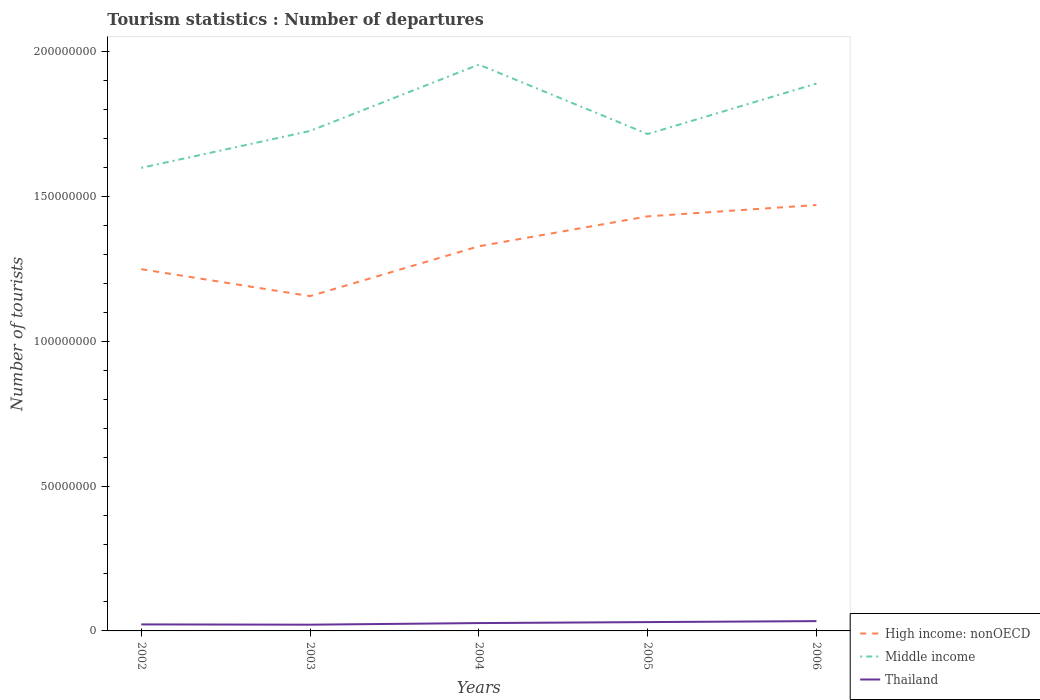How many different coloured lines are there?
Provide a succinct answer. 3. Does the line corresponding to Thailand intersect with the line corresponding to Middle income?
Your answer should be very brief. No. Across all years, what is the maximum number of tourist departures in High income: nonOECD?
Keep it short and to the point. 1.16e+08. What is the total number of tourist departures in Thailand in the graph?
Provide a succinct answer. -3.38e+05. What is the difference between the highest and the second highest number of tourist departures in Thailand?
Offer a very short reply. 1.23e+06. Is the number of tourist departures in Thailand strictly greater than the number of tourist departures in Middle income over the years?
Make the answer very short. Yes. How many lines are there?
Offer a terse response. 3. How many years are there in the graph?
Keep it short and to the point. 5. What is the title of the graph?
Your answer should be very brief. Tourism statistics : Number of departures. Does "Lao PDR" appear as one of the legend labels in the graph?
Give a very brief answer. No. What is the label or title of the Y-axis?
Make the answer very short. Number of tourists. What is the Number of tourists of High income: nonOECD in 2002?
Make the answer very short. 1.25e+08. What is the Number of tourists in Middle income in 2002?
Keep it short and to the point. 1.60e+08. What is the Number of tourists in Thailand in 2002?
Provide a succinct answer. 2.25e+06. What is the Number of tourists in High income: nonOECD in 2003?
Your answer should be very brief. 1.16e+08. What is the Number of tourists of Middle income in 2003?
Your answer should be compact. 1.73e+08. What is the Number of tourists of Thailand in 2003?
Give a very brief answer. 2.15e+06. What is the Number of tourists in High income: nonOECD in 2004?
Keep it short and to the point. 1.33e+08. What is the Number of tourists of Middle income in 2004?
Provide a short and direct response. 1.96e+08. What is the Number of tourists in Thailand in 2004?
Keep it short and to the point. 2.71e+06. What is the Number of tourists in High income: nonOECD in 2005?
Provide a short and direct response. 1.43e+08. What is the Number of tourists of Middle income in 2005?
Provide a short and direct response. 1.72e+08. What is the Number of tourists of Thailand in 2005?
Provide a succinct answer. 3.05e+06. What is the Number of tourists in High income: nonOECD in 2006?
Provide a short and direct response. 1.47e+08. What is the Number of tourists in Middle income in 2006?
Keep it short and to the point. 1.89e+08. What is the Number of tourists of Thailand in 2006?
Ensure brevity in your answer.  3.38e+06. Across all years, what is the maximum Number of tourists of High income: nonOECD?
Provide a succinct answer. 1.47e+08. Across all years, what is the maximum Number of tourists of Middle income?
Give a very brief answer. 1.96e+08. Across all years, what is the maximum Number of tourists in Thailand?
Offer a terse response. 3.38e+06. Across all years, what is the minimum Number of tourists of High income: nonOECD?
Provide a short and direct response. 1.16e+08. Across all years, what is the minimum Number of tourists in Middle income?
Offer a terse response. 1.60e+08. Across all years, what is the minimum Number of tourists in Thailand?
Provide a succinct answer. 2.15e+06. What is the total Number of tourists of High income: nonOECD in the graph?
Provide a succinct answer. 6.64e+08. What is the total Number of tourists in Middle income in the graph?
Provide a short and direct response. 8.89e+08. What is the total Number of tourists in Thailand in the graph?
Your answer should be compact. 1.35e+07. What is the difference between the Number of tourists of High income: nonOECD in 2002 and that in 2003?
Offer a very short reply. 9.30e+06. What is the difference between the Number of tourists of Middle income in 2002 and that in 2003?
Provide a short and direct response. -1.27e+07. What is the difference between the Number of tourists of Thailand in 2002 and that in 2003?
Your answer should be compact. 9.80e+04. What is the difference between the Number of tourists in High income: nonOECD in 2002 and that in 2004?
Make the answer very short. -7.91e+06. What is the difference between the Number of tourists of Middle income in 2002 and that in 2004?
Provide a succinct answer. -3.57e+07. What is the difference between the Number of tourists of Thailand in 2002 and that in 2004?
Your response must be concise. -4.59e+05. What is the difference between the Number of tourists in High income: nonOECD in 2002 and that in 2005?
Make the answer very short. -1.82e+07. What is the difference between the Number of tourists in Middle income in 2002 and that in 2005?
Offer a terse response. -1.17e+07. What is the difference between the Number of tourists of Thailand in 2002 and that in 2005?
Provide a short and direct response. -7.97e+05. What is the difference between the Number of tourists of High income: nonOECD in 2002 and that in 2006?
Offer a terse response. -2.22e+07. What is the difference between the Number of tourists of Middle income in 2002 and that in 2006?
Ensure brevity in your answer.  -2.91e+07. What is the difference between the Number of tourists in Thailand in 2002 and that in 2006?
Your answer should be compact. -1.13e+06. What is the difference between the Number of tourists in High income: nonOECD in 2003 and that in 2004?
Ensure brevity in your answer.  -1.72e+07. What is the difference between the Number of tourists in Middle income in 2003 and that in 2004?
Keep it short and to the point. -2.29e+07. What is the difference between the Number of tourists in Thailand in 2003 and that in 2004?
Provide a succinct answer. -5.57e+05. What is the difference between the Number of tourists of High income: nonOECD in 2003 and that in 2005?
Keep it short and to the point. -2.75e+07. What is the difference between the Number of tourists in Middle income in 2003 and that in 2005?
Make the answer very short. 1.05e+06. What is the difference between the Number of tourists in Thailand in 2003 and that in 2005?
Your answer should be very brief. -8.95e+05. What is the difference between the Number of tourists in High income: nonOECD in 2003 and that in 2006?
Provide a succinct answer. -3.15e+07. What is the difference between the Number of tourists in Middle income in 2003 and that in 2006?
Provide a short and direct response. -1.64e+07. What is the difference between the Number of tourists in Thailand in 2003 and that in 2006?
Offer a terse response. -1.23e+06. What is the difference between the Number of tourists of High income: nonOECD in 2004 and that in 2005?
Give a very brief answer. -1.03e+07. What is the difference between the Number of tourists of Middle income in 2004 and that in 2005?
Offer a terse response. 2.40e+07. What is the difference between the Number of tourists in Thailand in 2004 and that in 2005?
Provide a succinct answer. -3.38e+05. What is the difference between the Number of tourists in High income: nonOECD in 2004 and that in 2006?
Provide a short and direct response. -1.43e+07. What is the difference between the Number of tourists of Middle income in 2004 and that in 2006?
Provide a succinct answer. 6.56e+06. What is the difference between the Number of tourists of Thailand in 2004 and that in 2006?
Your answer should be compact. -6.73e+05. What is the difference between the Number of tourists of High income: nonOECD in 2005 and that in 2006?
Offer a very short reply. -3.92e+06. What is the difference between the Number of tourists in Middle income in 2005 and that in 2006?
Ensure brevity in your answer.  -1.74e+07. What is the difference between the Number of tourists of Thailand in 2005 and that in 2006?
Provide a short and direct response. -3.35e+05. What is the difference between the Number of tourists in High income: nonOECD in 2002 and the Number of tourists in Middle income in 2003?
Your answer should be very brief. -4.77e+07. What is the difference between the Number of tourists of High income: nonOECD in 2002 and the Number of tourists of Thailand in 2003?
Your answer should be compact. 1.23e+08. What is the difference between the Number of tourists of Middle income in 2002 and the Number of tourists of Thailand in 2003?
Keep it short and to the point. 1.58e+08. What is the difference between the Number of tourists of High income: nonOECD in 2002 and the Number of tourists of Middle income in 2004?
Ensure brevity in your answer.  -7.07e+07. What is the difference between the Number of tourists of High income: nonOECD in 2002 and the Number of tourists of Thailand in 2004?
Your response must be concise. 1.22e+08. What is the difference between the Number of tourists in Middle income in 2002 and the Number of tourists in Thailand in 2004?
Make the answer very short. 1.57e+08. What is the difference between the Number of tourists in High income: nonOECD in 2002 and the Number of tourists in Middle income in 2005?
Your answer should be compact. -4.67e+07. What is the difference between the Number of tourists of High income: nonOECD in 2002 and the Number of tourists of Thailand in 2005?
Offer a terse response. 1.22e+08. What is the difference between the Number of tourists of Middle income in 2002 and the Number of tourists of Thailand in 2005?
Offer a terse response. 1.57e+08. What is the difference between the Number of tourists in High income: nonOECD in 2002 and the Number of tourists in Middle income in 2006?
Give a very brief answer. -6.41e+07. What is the difference between the Number of tourists in High income: nonOECD in 2002 and the Number of tourists in Thailand in 2006?
Offer a terse response. 1.22e+08. What is the difference between the Number of tourists in Middle income in 2002 and the Number of tourists in Thailand in 2006?
Provide a succinct answer. 1.57e+08. What is the difference between the Number of tourists of High income: nonOECD in 2003 and the Number of tourists of Middle income in 2004?
Make the answer very short. -8.00e+07. What is the difference between the Number of tourists in High income: nonOECD in 2003 and the Number of tourists in Thailand in 2004?
Give a very brief answer. 1.13e+08. What is the difference between the Number of tourists of Middle income in 2003 and the Number of tourists of Thailand in 2004?
Keep it short and to the point. 1.70e+08. What is the difference between the Number of tourists in High income: nonOECD in 2003 and the Number of tourists in Middle income in 2005?
Ensure brevity in your answer.  -5.60e+07. What is the difference between the Number of tourists in High income: nonOECD in 2003 and the Number of tourists in Thailand in 2005?
Give a very brief answer. 1.13e+08. What is the difference between the Number of tourists in Middle income in 2003 and the Number of tourists in Thailand in 2005?
Offer a terse response. 1.70e+08. What is the difference between the Number of tourists of High income: nonOECD in 2003 and the Number of tourists of Middle income in 2006?
Ensure brevity in your answer.  -7.34e+07. What is the difference between the Number of tourists of High income: nonOECD in 2003 and the Number of tourists of Thailand in 2006?
Provide a succinct answer. 1.12e+08. What is the difference between the Number of tourists in Middle income in 2003 and the Number of tourists in Thailand in 2006?
Make the answer very short. 1.69e+08. What is the difference between the Number of tourists in High income: nonOECD in 2004 and the Number of tourists in Middle income in 2005?
Your answer should be very brief. -3.88e+07. What is the difference between the Number of tourists of High income: nonOECD in 2004 and the Number of tourists of Thailand in 2005?
Ensure brevity in your answer.  1.30e+08. What is the difference between the Number of tourists of Middle income in 2004 and the Number of tourists of Thailand in 2005?
Make the answer very short. 1.93e+08. What is the difference between the Number of tourists of High income: nonOECD in 2004 and the Number of tourists of Middle income in 2006?
Offer a terse response. -5.62e+07. What is the difference between the Number of tourists of High income: nonOECD in 2004 and the Number of tourists of Thailand in 2006?
Your answer should be very brief. 1.29e+08. What is the difference between the Number of tourists of Middle income in 2004 and the Number of tourists of Thailand in 2006?
Your answer should be compact. 1.92e+08. What is the difference between the Number of tourists of High income: nonOECD in 2005 and the Number of tourists of Middle income in 2006?
Provide a short and direct response. -4.59e+07. What is the difference between the Number of tourists of High income: nonOECD in 2005 and the Number of tourists of Thailand in 2006?
Your answer should be very brief. 1.40e+08. What is the difference between the Number of tourists in Middle income in 2005 and the Number of tourists in Thailand in 2006?
Your answer should be very brief. 1.68e+08. What is the average Number of tourists in High income: nonOECD per year?
Your answer should be very brief. 1.33e+08. What is the average Number of tourists of Middle income per year?
Offer a terse response. 1.78e+08. What is the average Number of tourists in Thailand per year?
Provide a short and direct response. 2.71e+06. In the year 2002, what is the difference between the Number of tourists in High income: nonOECD and Number of tourists in Middle income?
Provide a succinct answer. -3.50e+07. In the year 2002, what is the difference between the Number of tourists in High income: nonOECD and Number of tourists in Thailand?
Give a very brief answer. 1.23e+08. In the year 2002, what is the difference between the Number of tourists in Middle income and Number of tourists in Thailand?
Ensure brevity in your answer.  1.58e+08. In the year 2003, what is the difference between the Number of tourists in High income: nonOECD and Number of tourists in Middle income?
Give a very brief answer. -5.70e+07. In the year 2003, what is the difference between the Number of tourists in High income: nonOECD and Number of tourists in Thailand?
Your answer should be compact. 1.13e+08. In the year 2003, what is the difference between the Number of tourists of Middle income and Number of tourists of Thailand?
Your answer should be very brief. 1.70e+08. In the year 2004, what is the difference between the Number of tourists of High income: nonOECD and Number of tourists of Middle income?
Offer a terse response. -6.27e+07. In the year 2004, what is the difference between the Number of tourists of High income: nonOECD and Number of tourists of Thailand?
Your response must be concise. 1.30e+08. In the year 2004, what is the difference between the Number of tourists in Middle income and Number of tourists in Thailand?
Give a very brief answer. 1.93e+08. In the year 2005, what is the difference between the Number of tourists in High income: nonOECD and Number of tourists in Middle income?
Provide a succinct answer. -2.84e+07. In the year 2005, what is the difference between the Number of tourists of High income: nonOECD and Number of tourists of Thailand?
Your response must be concise. 1.40e+08. In the year 2005, what is the difference between the Number of tourists of Middle income and Number of tourists of Thailand?
Provide a succinct answer. 1.69e+08. In the year 2006, what is the difference between the Number of tourists of High income: nonOECD and Number of tourists of Middle income?
Make the answer very short. -4.19e+07. In the year 2006, what is the difference between the Number of tourists in High income: nonOECD and Number of tourists in Thailand?
Offer a terse response. 1.44e+08. In the year 2006, what is the difference between the Number of tourists of Middle income and Number of tourists of Thailand?
Keep it short and to the point. 1.86e+08. What is the ratio of the Number of tourists of High income: nonOECD in 2002 to that in 2003?
Give a very brief answer. 1.08. What is the ratio of the Number of tourists in Middle income in 2002 to that in 2003?
Offer a very short reply. 0.93. What is the ratio of the Number of tourists of Thailand in 2002 to that in 2003?
Your answer should be very brief. 1.05. What is the ratio of the Number of tourists in High income: nonOECD in 2002 to that in 2004?
Offer a very short reply. 0.94. What is the ratio of the Number of tourists in Middle income in 2002 to that in 2004?
Your response must be concise. 0.82. What is the ratio of the Number of tourists in Thailand in 2002 to that in 2004?
Your answer should be compact. 0.83. What is the ratio of the Number of tourists of High income: nonOECD in 2002 to that in 2005?
Offer a very short reply. 0.87. What is the ratio of the Number of tourists of Middle income in 2002 to that in 2005?
Your answer should be very brief. 0.93. What is the ratio of the Number of tourists in Thailand in 2002 to that in 2005?
Keep it short and to the point. 0.74. What is the ratio of the Number of tourists in High income: nonOECD in 2002 to that in 2006?
Give a very brief answer. 0.85. What is the ratio of the Number of tourists of Middle income in 2002 to that in 2006?
Offer a terse response. 0.85. What is the ratio of the Number of tourists of Thailand in 2002 to that in 2006?
Offer a terse response. 0.67. What is the ratio of the Number of tourists of High income: nonOECD in 2003 to that in 2004?
Provide a short and direct response. 0.87. What is the ratio of the Number of tourists of Middle income in 2003 to that in 2004?
Keep it short and to the point. 0.88. What is the ratio of the Number of tourists of Thailand in 2003 to that in 2004?
Make the answer very short. 0.79. What is the ratio of the Number of tourists of High income: nonOECD in 2003 to that in 2005?
Ensure brevity in your answer.  0.81. What is the ratio of the Number of tourists of Middle income in 2003 to that in 2005?
Ensure brevity in your answer.  1.01. What is the ratio of the Number of tourists in Thailand in 2003 to that in 2005?
Provide a short and direct response. 0.71. What is the ratio of the Number of tourists in High income: nonOECD in 2003 to that in 2006?
Your answer should be compact. 0.79. What is the ratio of the Number of tourists of Middle income in 2003 to that in 2006?
Provide a short and direct response. 0.91. What is the ratio of the Number of tourists in Thailand in 2003 to that in 2006?
Your response must be concise. 0.64. What is the ratio of the Number of tourists of High income: nonOECD in 2004 to that in 2005?
Offer a terse response. 0.93. What is the ratio of the Number of tourists in Middle income in 2004 to that in 2005?
Provide a short and direct response. 1.14. What is the ratio of the Number of tourists in Thailand in 2004 to that in 2005?
Your response must be concise. 0.89. What is the ratio of the Number of tourists of High income: nonOECD in 2004 to that in 2006?
Offer a terse response. 0.9. What is the ratio of the Number of tourists in Middle income in 2004 to that in 2006?
Keep it short and to the point. 1.03. What is the ratio of the Number of tourists of Thailand in 2004 to that in 2006?
Keep it short and to the point. 0.8. What is the ratio of the Number of tourists in High income: nonOECD in 2005 to that in 2006?
Your response must be concise. 0.97. What is the ratio of the Number of tourists of Middle income in 2005 to that in 2006?
Your answer should be very brief. 0.91. What is the ratio of the Number of tourists of Thailand in 2005 to that in 2006?
Provide a short and direct response. 0.9. What is the difference between the highest and the second highest Number of tourists in High income: nonOECD?
Keep it short and to the point. 3.92e+06. What is the difference between the highest and the second highest Number of tourists in Middle income?
Make the answer very short. 6.56e+06. What is the difference between the highest and the second highest Number of tourists of Thailand?
Provide a short and direct response. 3.35e+05. What is the difference between the highest and the lowest Number of tourists in High income: nonOECD?
Offer a terse response. 3.15e+07. What is the difference between the highest and the lowest Number of tourists of Middle income?
Give a very brief answer. 3.57e+07. What is the difference between the highest and the lowest Number of tourists of Thailand?
Make the answer very short. 1.23e+06. 